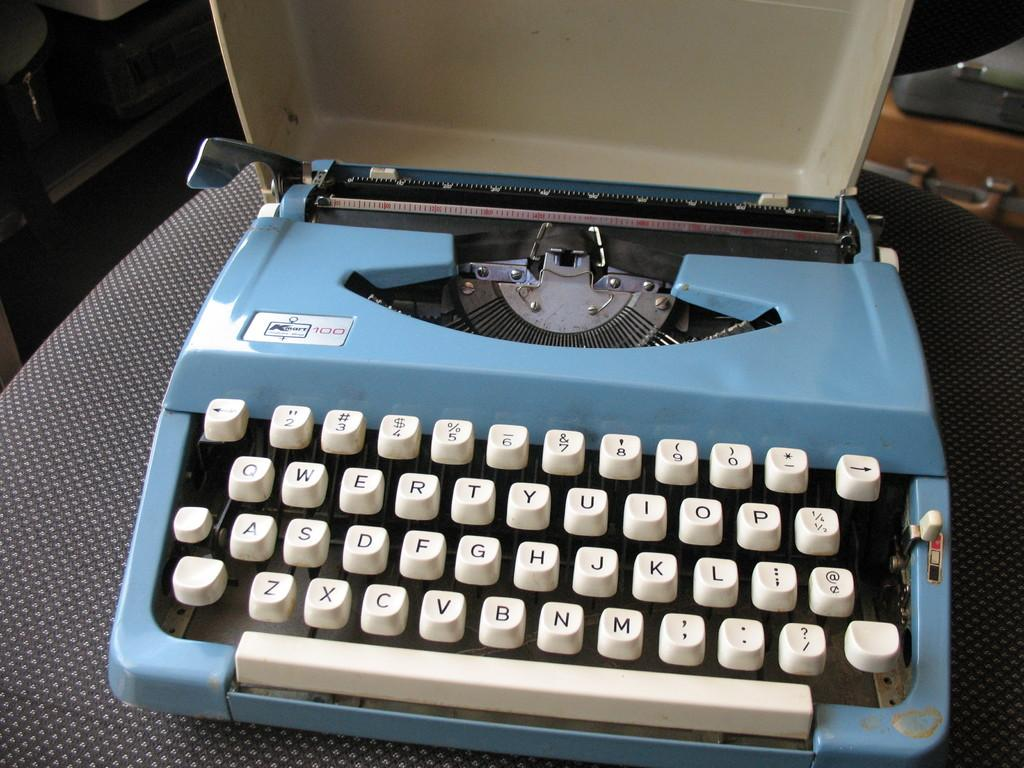<image>
Present a compact description of the photo's key features. A blue Kmart typewriter is sitting with its top open. 